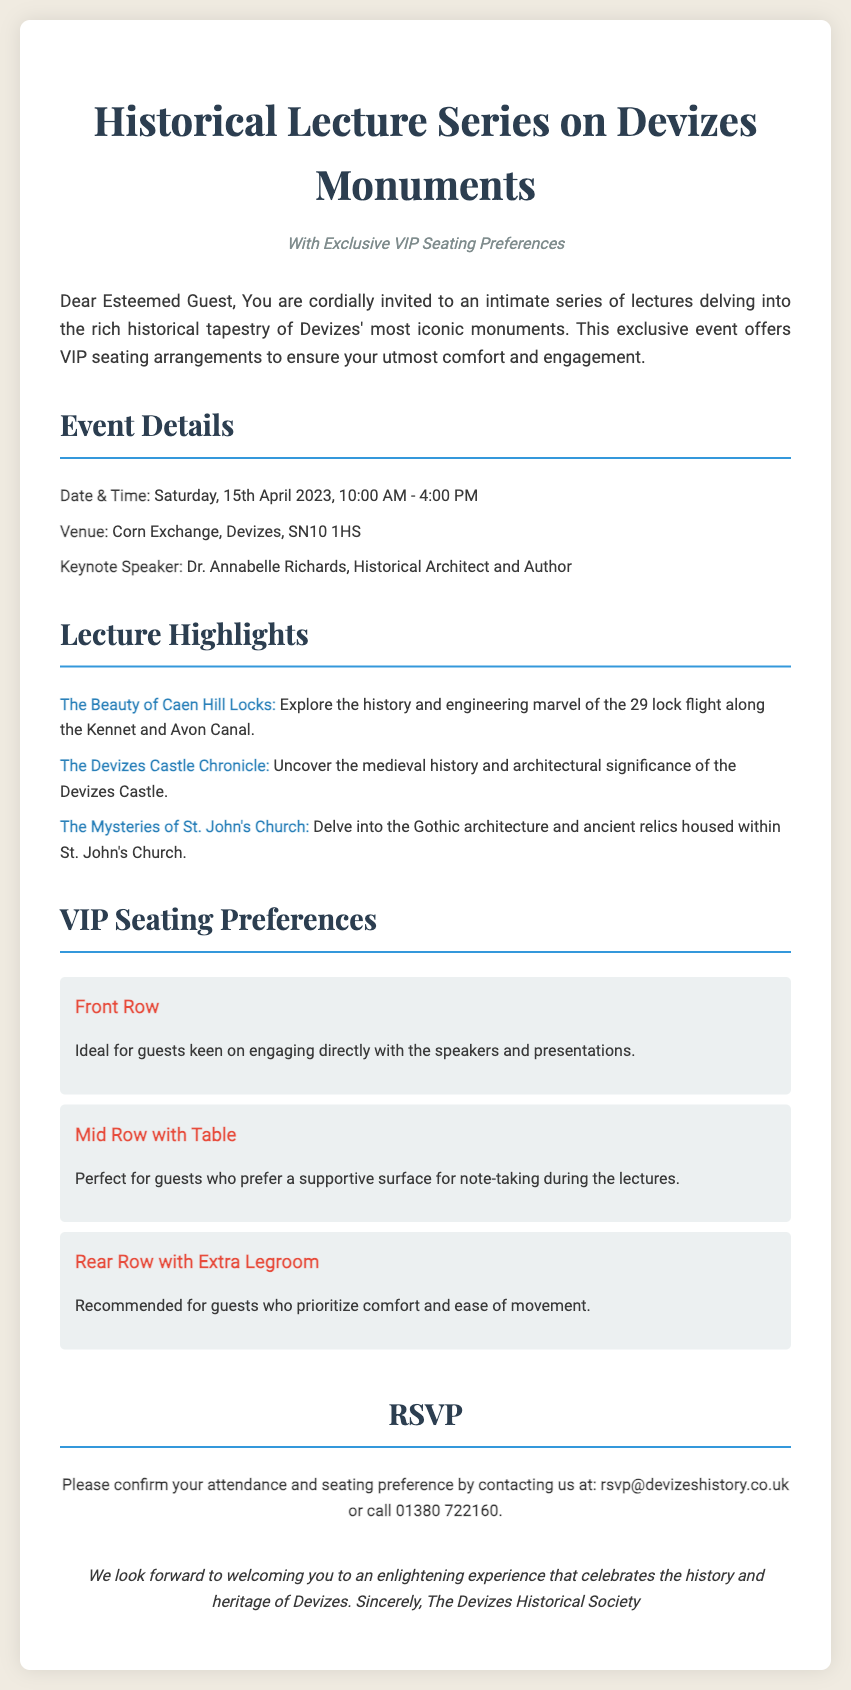What is the date of the event? The event takes place on Saturday, 15th April 2023, as mentioned in the document.
Answer: 15th April 2023 Who is the keynote speaker? The keynote speaker is Dr. Annabelle Richards, Historical Architect and Author.
Answer: Dr. Annabelle Richards What venue will host the lectures? The venue stated in the document is the Corn Exchange, Devizes, SN10 1HS.
Answer: Corn Exchange, Devizes, SN10 1HS What is one of the lecture highlights? One of the highlights mentioned is "The Beauty of Caen Hill Locks," focusing on the history and engineering marvel.
Answer: The Beauty of Caen Hill Locks Which VIP seating option is ideal for direct engagement? The Front Row seating is ideal for guests keen on engaging directly with the speakers and presentations.
Answer: Front Row What time does the event start? The event starts at 10:00 AM, as indicated in the event details section.
Answer: 10:00 AM How can attendees confirm their attendance? Attendees can confirm their attendance by contacting the provided email or phone number in the RSVP section.
Answer: rsvp@devizeshistory.co.uk or call 01380 722160 What seating option is perfect for note-taking? The Mid Row with Table seating is described as perfect for those who prefer a supportive surface for note-taking.
Answer: Mid Row with Table What is emphasized in the closing text? The closing text emphasizes looking forward to welcoming guests to an enlightening experience.
Answer: Welcoming you to an enlightening experience 